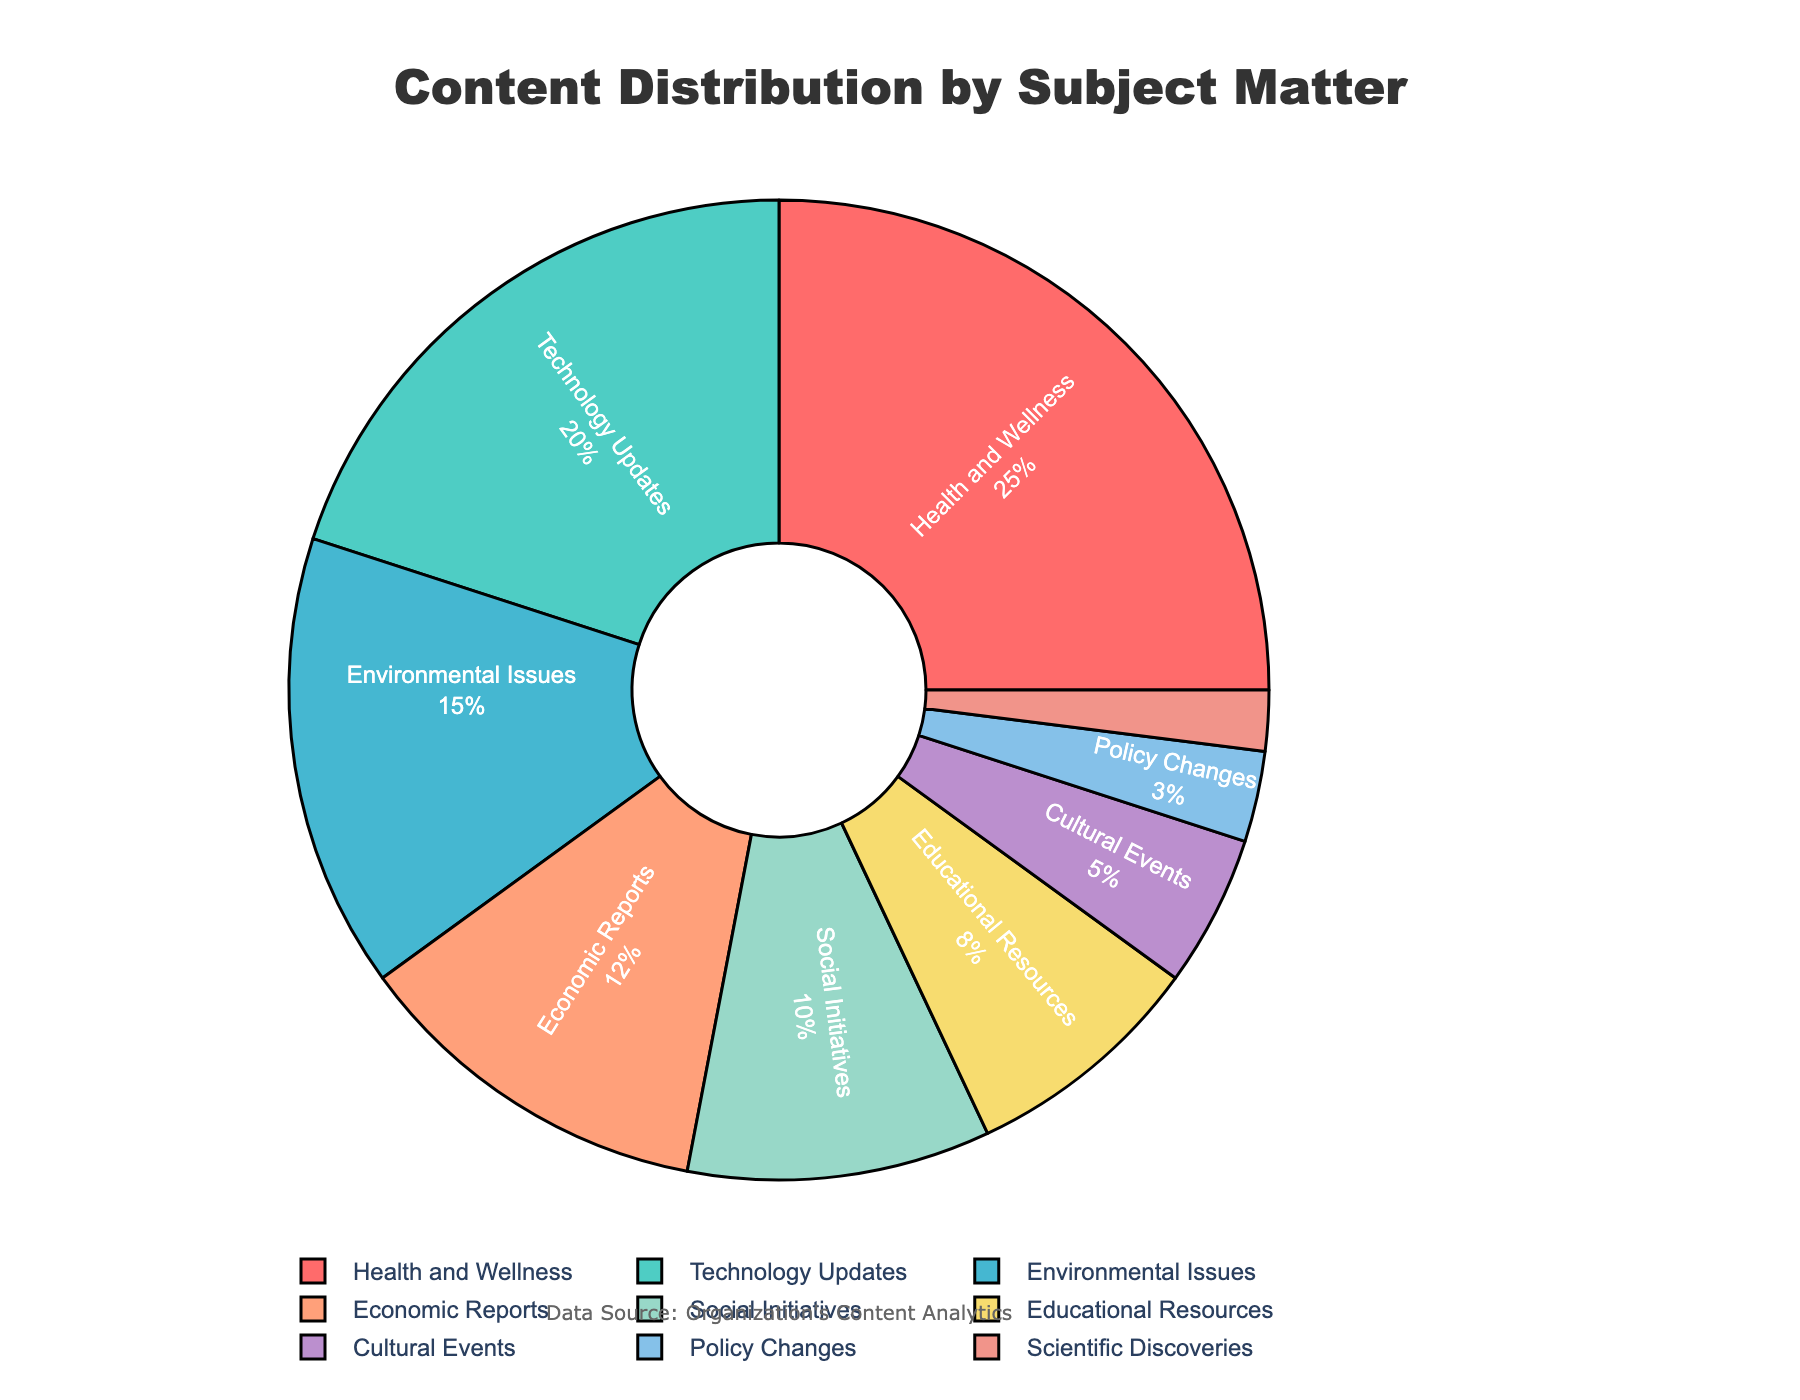Which subject has the highest percentage of content shared? The subject with the highest percentage of content can be determined by looking at the largest slice of the pie chart. In this case, it is "Health and Wellness" with 25%
Answer: Health and Wellness Which subjects have a combined percentage of more than 50%? To find the combined percentage of more than 50%, we need to sum the percentages of the largest slices until we exceed 50%. Adding "Health and Wellness" (25%), "Technology Updates" (20%), and "Environmental Issues" (15%) gives us 60%, which is greater than 50%
Answer: Health and Wellness, Technology Updates, Environmental Issues What is the difference in percentage between Technology Updates and Educational Resources? Subtract the percentage of Educational Resources (8%) from the percentage of Technology Updates (20%). 20% - 8% = 12%
Answer: 12% Which subjects have an equal combined percentage of the sum of Economic Reports and Social Initiatives? The sum of Economic Reports (12%) and Social Initiatives (10%) is 22%. The subjects "Technology Updates" (20%) and "Scientific Discoveries" (2%) have a combined percentage of 22%.
Answer: Technology Updates, Scientific Discoveries Which subject has the smallest percentage of content shared and what is its value? The smallest slice in the pie chart represents the subject with the smallest percentage. "Scientific Discoveries" has the smallest percentage with 2%
Answer: Scientific Discoveries, 2% Is the percentage of Cultural Events greater than that of Policy Changes? We need to compare the percentages of Cultural Events (5%) and Policy Changes (3%). 5% is greater than 3%
Answer: Yes How does the percentage of Environmental Issues compare to Social Initiatives? The percentage of Environmental Issues (15%) is greater than the percentage of Social Initiatives (10%)
Answer: Environmental Issues If you combine the percentages of Social Initiatives, Educational Resources, and Cultural Events, what is their total percentage? Adding the percentages of Social Initiatives (10%), Educational Resources (8%), and Cultural Events (5%) gives us 10% + 8% + 5% = 23%
Answer: 23% Which subjects together account for exactly 20% of the content shared? The only subject that accounts for exactly 20% is "Technology Updates"
Answer: Technology Updates How much more content is focused on Health and Wellness compared to Economic Reports? To find the difference, subtract the percentage of Economic Reports (12%) from Health and Wellness (25%). 25% - 12% = 13%
Answer: 13% 